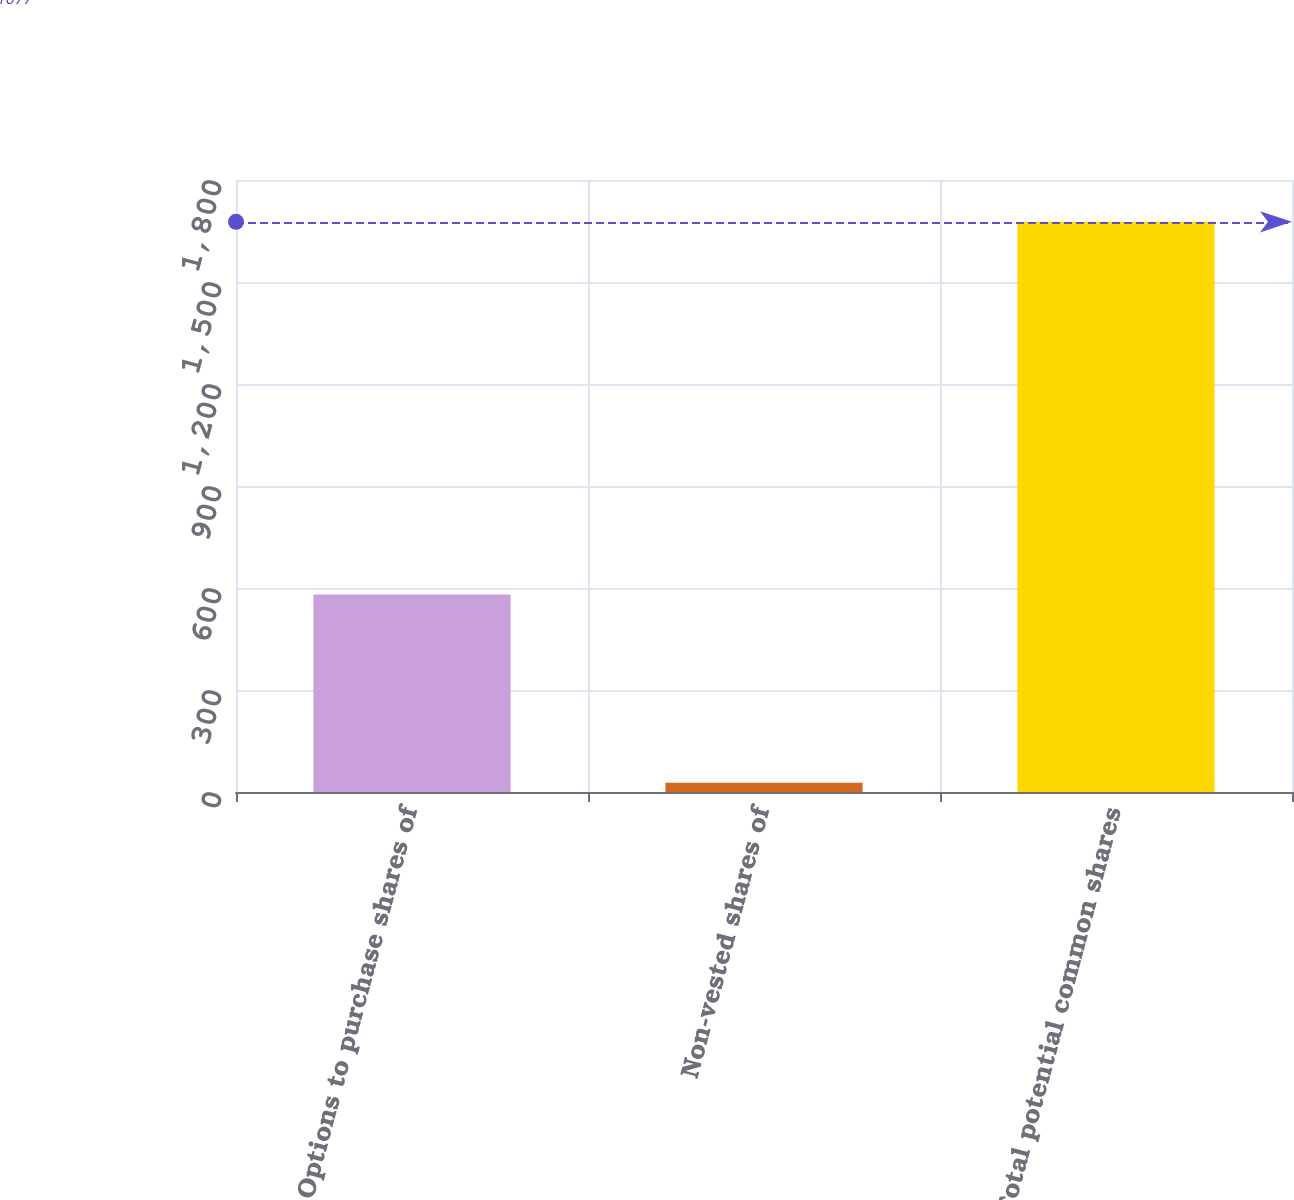<chart> <loc_0><loc_0><loc_500><loc_500><bar_chart><fcel>Options to purchase shares of<fcel>Non-vested shares of<fcel>Total potential common shares<nl><fcel>581<fcel>27<fcel>1677<nl></chart> 